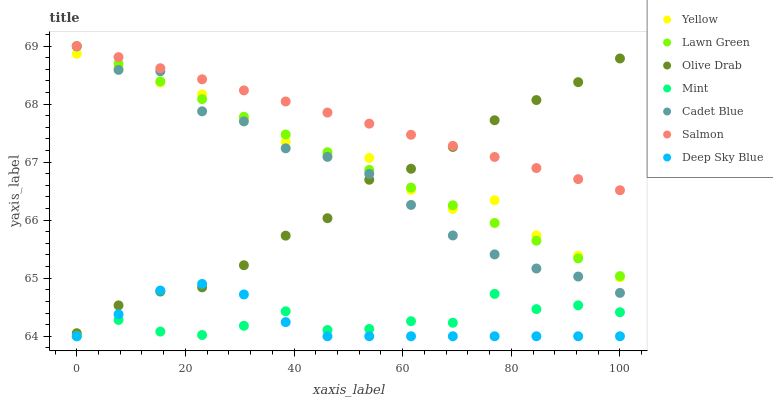Does Deep Sky Blue have the minimum area under the curve?
Answer yes or no. Yes. Does Salmon have the maximum area under the curve?
Answer yes or no. Yes. Does Cadet Blue have the minimum area under the curve?
Answer yes or no. No. Does Cadet Blue have the maximum area under the curve?
Answer yes or no. No. Is Lawn Green the smoothest?
Answer yes or no. Yes. Is Mint the roughest?
Answer yes or no. Yes. Is Cadet Blue the smoothest?
Answer yes or no. No. Is Cadet Blue the roughest?
Answer yes or no. No. Does Deep Sky Blue have the lowest value?
Answer yes or no. Yes. Does Cadet Blue have the lowest value?
Answer yes or no. No. Does Salmon have the highest value?
Answer yes or no. Yes. Does Cadet Blue have the highest value?
Answer yes or no. No. Is Mint less than Cadet Blue?
Answer yes or no. Yes. Is Lawn Green greater than Mint?
Answer yes or no. Yes. Does Deep Sky Blue intersect Mint?
Answer yes or no. Yes. Is Deep Sky Blue less than Mint?
Answer yes or no. No. Is Deep Sky Blue greater than Mint?
Answer yes or no. No. Does Mint intersect Cadet Blue?
Answer yes or no. No. 